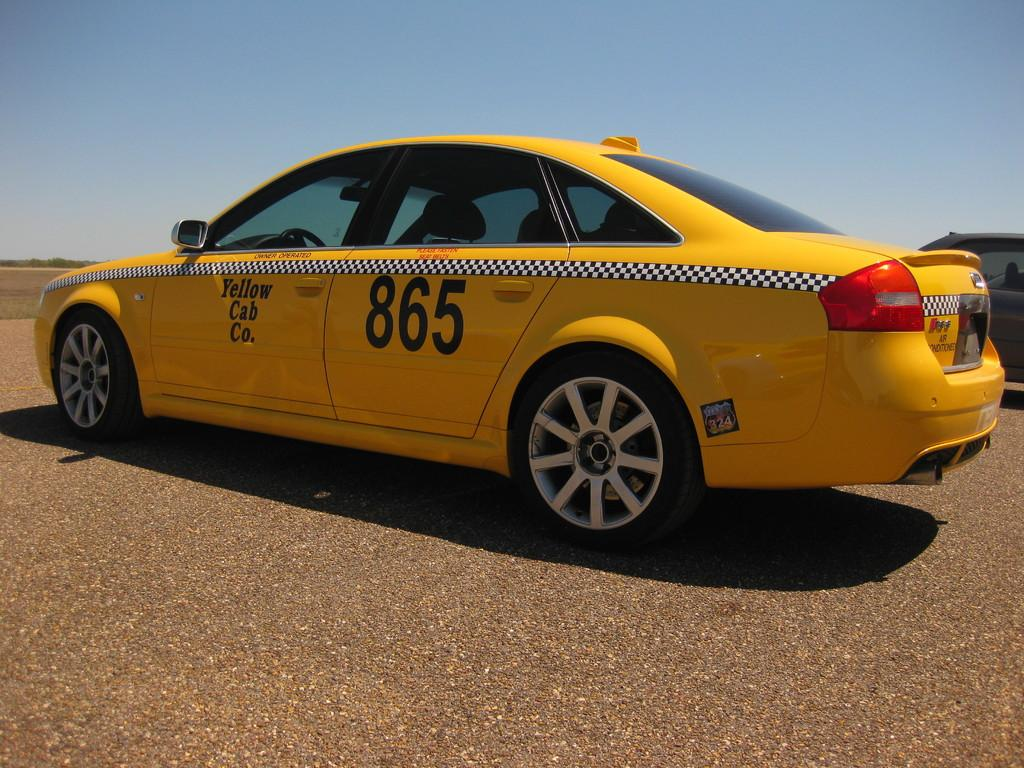<image>
Describe the image concisely. a taxi with the numbers 865 on it 